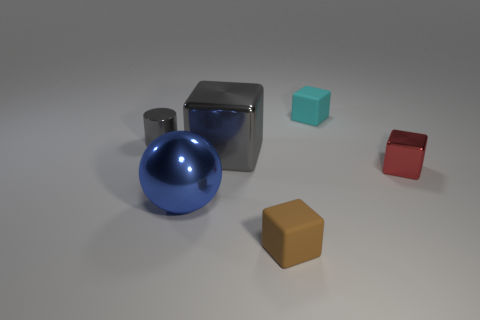Subtract all tiny blocks. How many blocks are left? 1 Add 1 big purple matte blocks. How many objects exist? 7 Subtract all tiny cyan rubber things. Subtract all gray shiny things. How many objects are left? 3 Add 1 cylinders. How many cylinders are left? 2 Add 2 small cyan matte cubes. How many small cyan matte cubes exist? 3 Subtract all gray cubes. How many cubes are left? 3 Subtract 1 blue balls. How many objects are left? 5 Subtract all blocks. How many objects are left? 2 Subtract 1 cylinders. How many cylinders are left? 0 Subtract all yellow blocks. Subtract all green cylinders. How many blocks are left? 4 